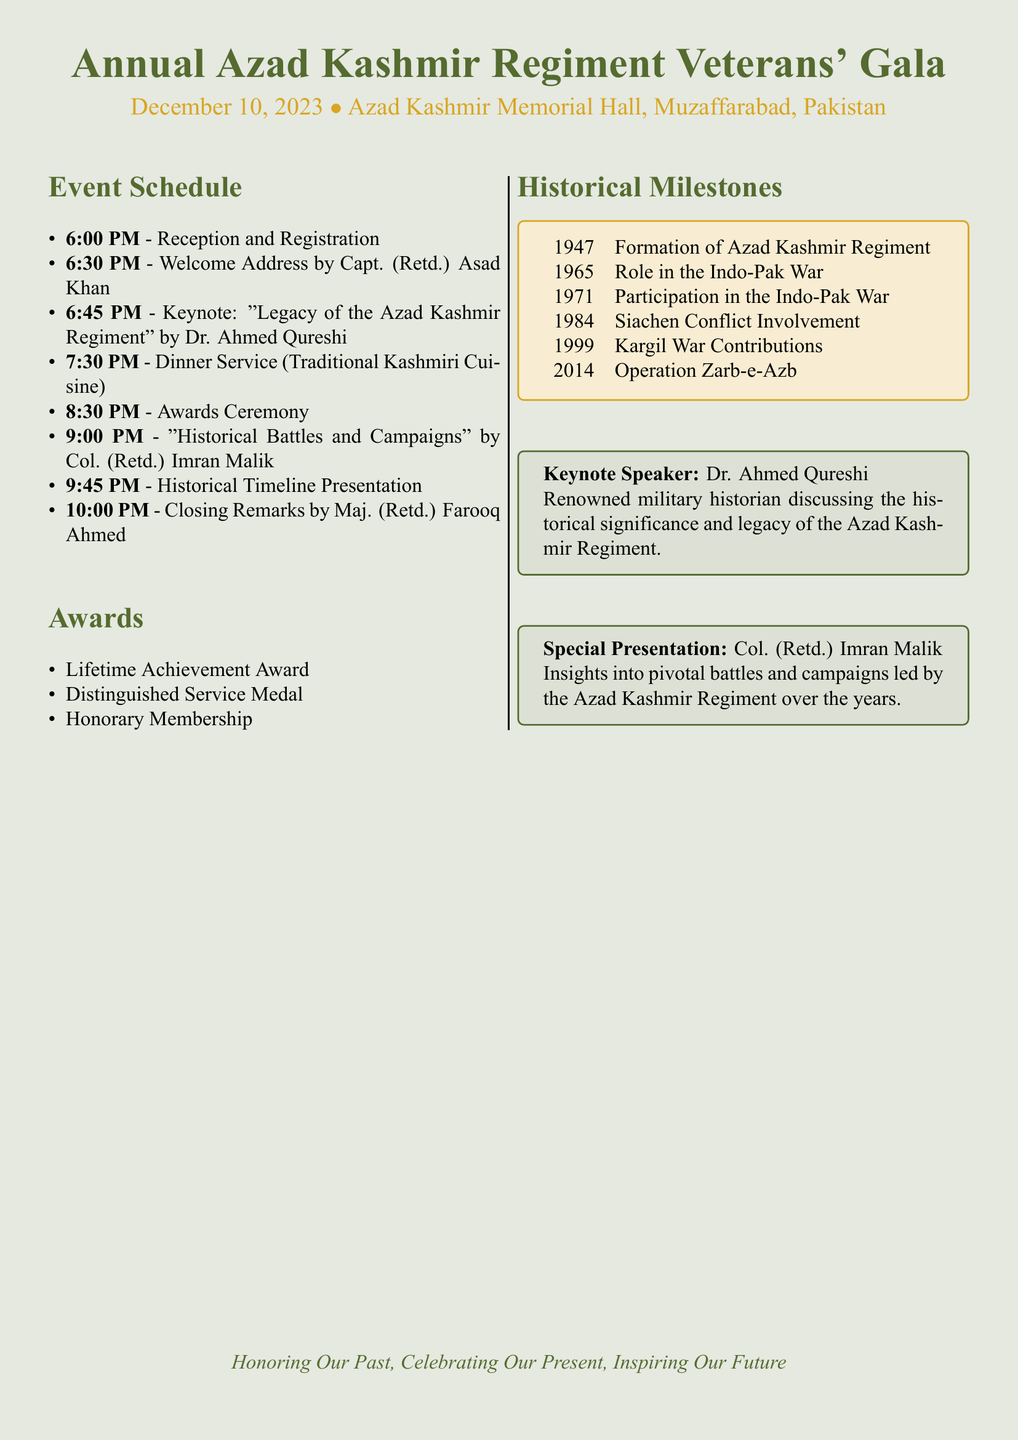What is the date of the event? The date of the event is mentioned clearly in the program, which is December 10, 2023.
Answer: December 10, 2023 Who is delivering the welcome address? The welcome address is given by Capt. (Retd.) Asad Khan as listed in the schedule.
Answer: Capt. (Retd.) Asad Khan What time does the awards ceremony start? The schedule provides a specific time for the awards ceremony, which is 8:30 PM.
Answer: 8:30 PM What award is not listed in the awards section? By reviewing the awards section, we can identify what is not mentioned; the “Best Newcomer Award” is not listed.
Answer: Best Newcomer Award Which speaker is discussing "Historical Battles and Campaigns"? The speaker noted for discussing "Historical Battles and Campaigns" is Col. (Retd.) Imran Malik.
Answer: Col. (Retd.) Imran Malik How many historical milestones are listed in the document? By counting the entries under the Historical Milestones section, the total number is five.
Answer: Five What is the theme stated at the end of the document? The concluding theme of the document emphasizes honoring the past, celebrating the present, and inspiring the future.
Answer: Honoring Our Past, Celebrating Our Present, Inspiring Our Future What type of cuisine is served during dinner? The type of cuisine for the dinner service is specified as "Traditional Kashmiri Cuisine".
Answer: Traditional Kashmiri Cuisine 